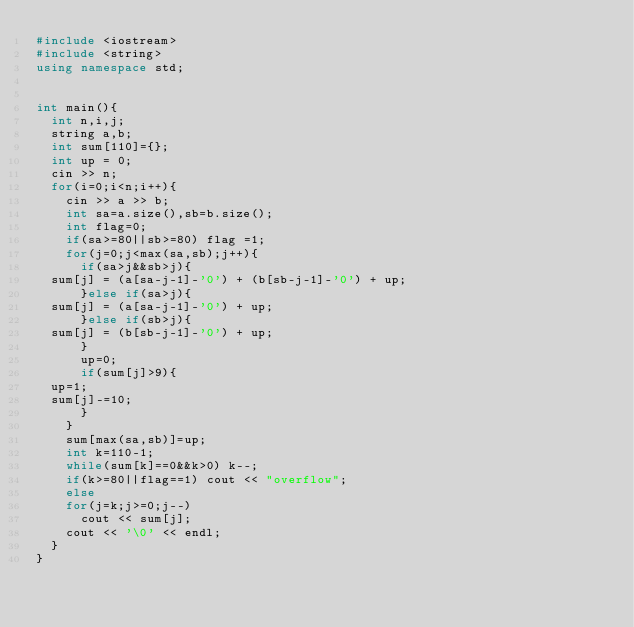Convert code to text. <code><loc_0><loc_0><loc_500><loc_500><_C++_>#include <iostream>
#include <string>
using namespace std;


int main(){
  int n,i,j;
  string a,b;
  int sum[110]={};
  int up = 0;
  cin >> n;
  for(i=0;i<n;i++){
    cin >> a >> b;
    int sa=a.size(),sb=b.size();
    int flag=0;
    if(sa>=80||sb>=80) flag =1;
    for(j=0;j<max(sa,sb);j++){
      if(sa>j&&sb>j){
	sum[j] = (a[sa-j-1]-'0') + (b[sb-j-1]-'0') + up;
      }else if(sa>j){
	sum[j] = (a[sa-j-1]-'0') + up;
      }else if(sb>j){
	sum[j] = (b[sb-j-1]-'0') + up;
      }
      up=0;
      if(sum[j]>9){
	up=1;
	sum[j]-=10;
      }
    }
    sum[max(sa,sb)]=up;
    int k=110-1;
    while(sum[k]==0&&k>0) k--;
    if(k>=80||flag==1) cout << "overflow";
    else
    for(j=k;j>=0;j--)
      cout << sum[j];
    cout << '\0' << endl;
  }
}</code> 